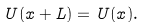Convert formula to latex. <formula><loc_0><loc_0><loc_500><loc_500>U ( x + L ) = U ( x ) .</formula> 